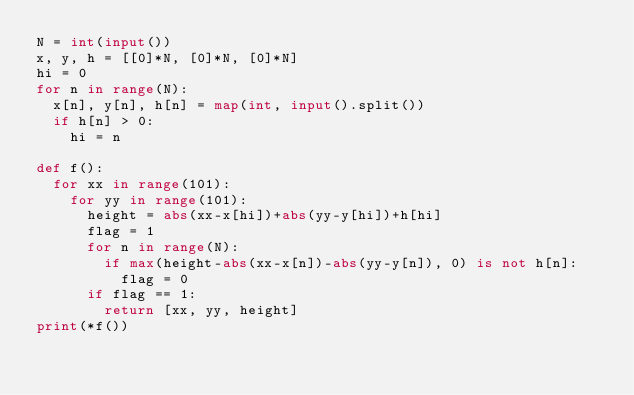<code> <loc_0><loc_0><loc_500><loc_500><_Python_>N = int(input())
x, y, h = [[0]*N, [0]*N, [0]*N]
hi = 0
for n in range(N):
  x[n], y[n], h[n] = map(int, input().split())
  if h[n] > 0:
    hi = n

def f():
  for xx in range(101):
    for yy in range(101):
      height = abs(xx-x[hi])+abs(yy-y[hi])+h[hi]
      flag = 1
      for n in range(N):
        if max(height-abs(xx-x[n])-abs(yy-y[n]), 0) is not h[n]:
          flag = 0
      if flag == 1:
        return [xx, yy, height]
print(*f())</code> 